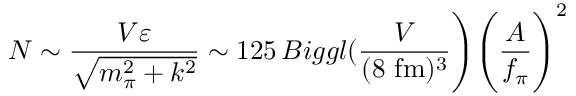Convert formula to latex. <formula><loc_0><loc_0><loc_500><loc_500>N \sim \frac { V \varepsilon } { \sqrt { m _ { \pi } ^ { 2 } + k ^ { 2 } } } \sim 1 2 5 \, B i g g l ( \frac { V } { ( 8 f m ) ^ { 3 } } \Big ) \Big ( \frac { A } { f _ { \pi } } \Big ) ^ { 2 }</formula> 